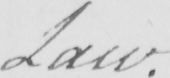What is written in this line of handwriting? Law . 